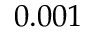<formula> <loc_0><loc_0><loc_500><loc_500>0 . 0 0 1</formula> 